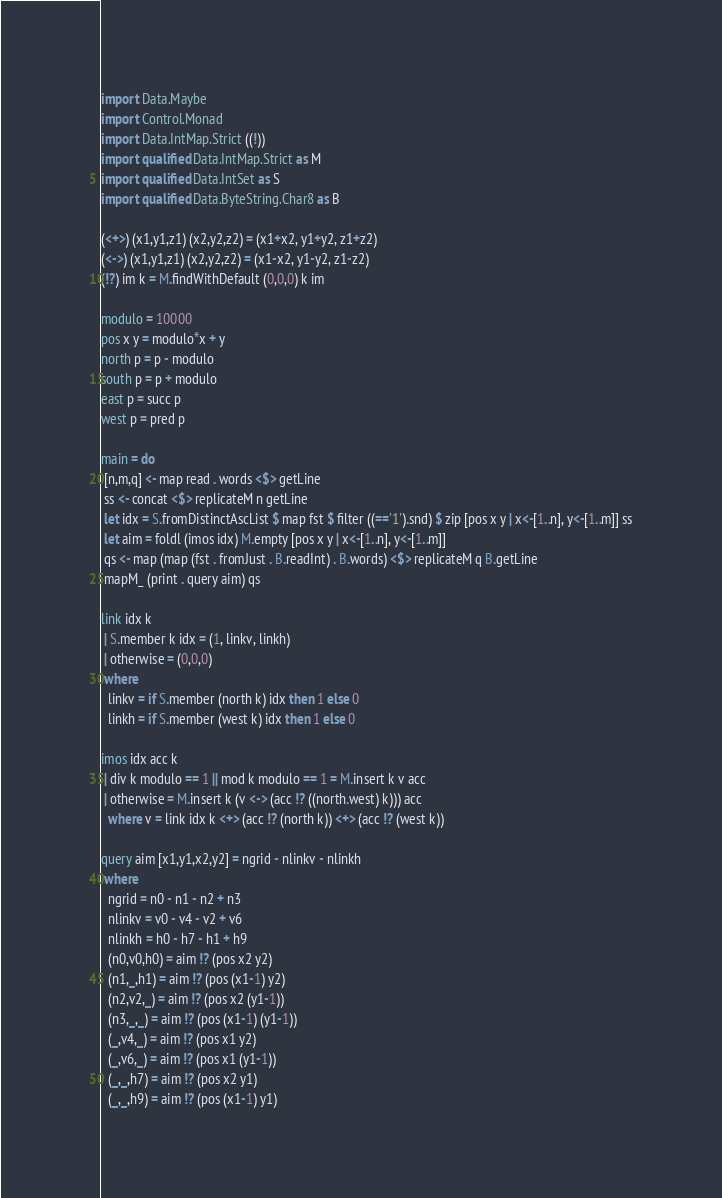Convert code to text. <code><loc_0><loc_0><loc_500><loc_500><_Haskell_>import Data.Maybe
import Control.Monad
import Data.IntMap.Strict ((!))
import qualified Data.IntMap.Strict as M
import qualified Data.IntSet as S 
import qualified Data.ByteString.Char8 as B

(<+>) (x1,y1,z1) (x2,y2,z2) = (x1+x2, y1+y2, z1+z2)
(<->) (x1,y1,z1) (x2,y2,z2) = (x1-x2, y1-y2, z1-z2)
(!?) im k = M.findWithDefault (0,0,0) k im

modulo = 10000
pos x y = modulo*x + y
north p = p - modulo
south p = p + modulo
east p = succ p
west p = pred p

main = do
 [n,m,q] <- map read . words <$> getLine
 ss <- concat <$> replicateM n getLine
 let idx = S.fromDistinctAscList $ map fst $ filter ((=='1').snd) $ zip [pos x y | x<-[1..n], y<-[1..m]] ss
 let aim = foldl (imos idx) M.empty [pos x y | x<-[1..n], y<-[1..m]]
 qs <- map (map (fst . fromJust . B.readInt) . B.words) <$> replicateM q B.getLine
 mapM_ (print . query aim) qs

link idx k
 | S.member k idx = (1, linkv, linkh)
 | otherwise = (0,0,0)
 where
  linkv = if S.member (north k) idx then 1 else 0
  linkh = if S.member (west k) idx then 1 else 0

imos idx acc k
 | div k modulo == 1 || mod k modulo == 1 = M.insert k v acc
 | otherwise = M.insert k (v <-> (acc !? ((north.west) k))) acc
  where v = link idx k <+> (acc !? (north k)) <+> (acc !? (west k))

query aim [x1,y1,x2,y2] = ngrid - nlinkv - nlinkh
 where 
  ngrid = n0 - n1 - n2 + n3
  nlinkv = v0 - v4 - v2 + v6
  nlinkh = h0 - h7 - h1 + h9
  (n0,v0,h0) = aim !? (pos x2 y2)
  (n1,_,h1) = aim !? (pos (x1-1) y2)
  (n2,v2,_) = aim !? (pos x2 (y1-1))
  (n3,_,_) = aim !? (pos (x1-1) (y1-1))
  (_,v4,_) = aim !? (pos x1 y2)
  (_,v6,_) = aim !? (pos x1 (y1-1))
  (_,_,h7) = aim !? (pos x2 y1)
  (_,_,h9) = aim !? (pos (x1-1) y1)</code> 